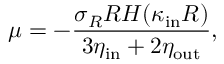<formula> <loc_0><loc_0><loc_500><loc_500>\mu = - \frac { \sigma _ { R } R H ( \kappa _ { i n } R ) } { 3 \eta _ { i n } + 2 \eta _ { o u t } } ,</formula> 